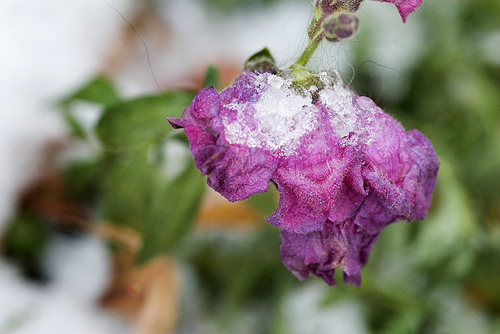<image>
Can you confirm if the snow is in the flower? Yes. The snow is contained within or inside the flower, showing a containment relationship. 